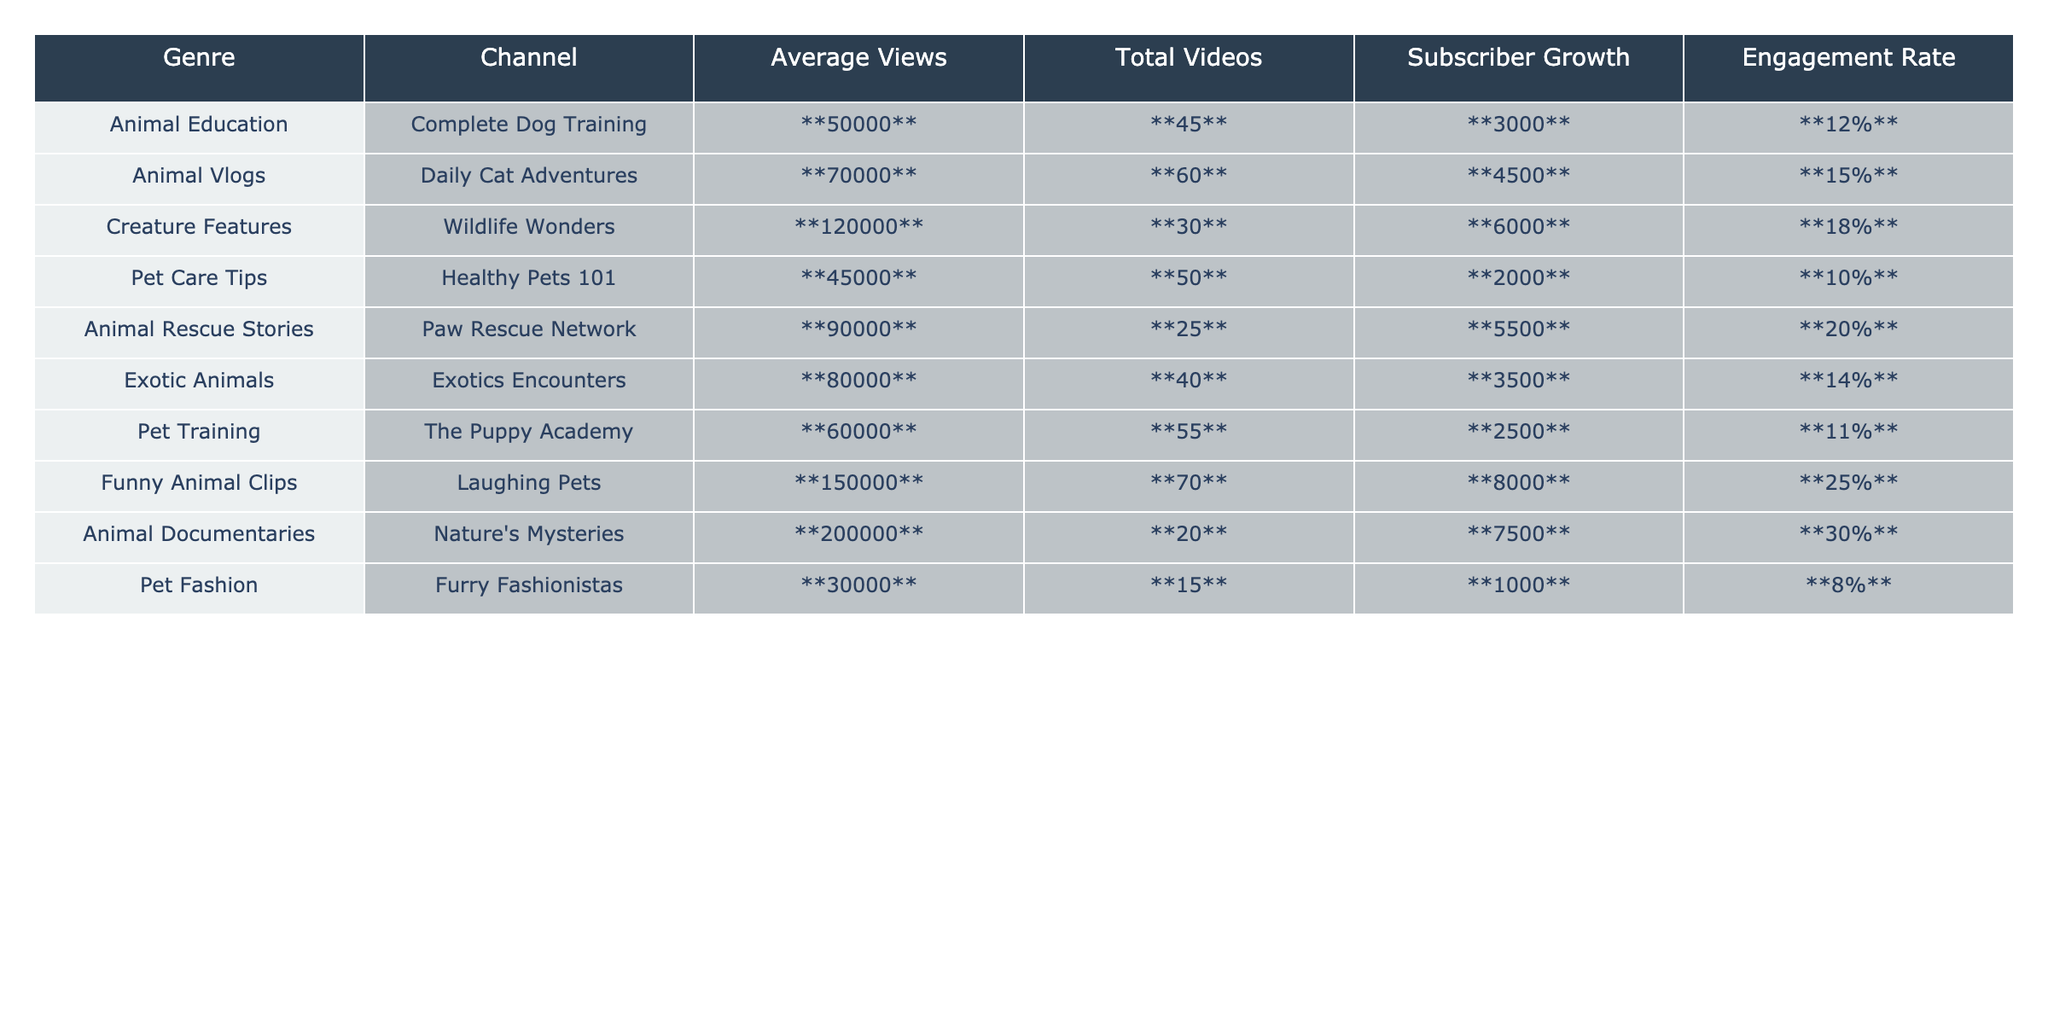What is the average views for the video genre "Funny Animal Clips"? The table indicates that "Funny Animal Clips" has an average of **150000** views according to the data provided.
Answer: 150000 Which video genre has the highest engagement rate? From the table, "Animal Documentaries" has the highest engagement rate of **30%**.
Answer: 30% How many total videos are there in the "Animal Education" genre? The data for "Animal Education" shows that there are **45** total videos according to the table.
Answer: 45 What is the total subscriber growth across all genres? By adding the subscriber growth of each genre: 3000 + 4500 + 6000 + 2000 + 5500 + 3500 + 2500 + 8000 + 7500 + 1000 = 36000.
Answer: 36000 Which channel has the lowest average views, and what is that number? The channel "Pet Fashion" has the lowest average views of **30000** per the table data.
Answer: 30000 Is the engagement rate for "Pet Care Tips" greater than 12%? According to the table, "Pet Care Tips" has an engagement rate of **10%**, which is not greater than 12%.
Answer: No How does the average views of "Creature Features" compare to "Animal Rescue Stories"? "Creature Features" has an average of **120000** views, while "Animal Rescue Stories" has **90000** views. Since 120000 is greater than 90000, "Creature Features" has a higher average views.
Answer: Higher If we average the engagement rates of all genres, what would that be? The total engagement rates are 12% + 15% + 18% + 10% + 20% + 14% + 11% + 25% + 30% + 8% =  10 rates, yielding an average of (12 + 15 + 18 + 10 + 20 + 14 + 11 + 25 + 30 + 8) / 10 = 16.
Answer: 16 Which genre has the highest average views and combination of total videos less than 50? "Pet Training" (60000 views, 55 videos) and "Animal Rescue Stories" (90000 views, 25 videos) are the options. With total videos less than 50, "Animal Rescue Stories" has 90000 views, thus it is the highest with this condition.
Answer: Animal Rescue Stories What percentage of total videos does the "Exotic Animals" genre represent among all genres? The total number of videos across all genres is 45 + 60 + 30 + 50 + 25 + 40 + 55 + 70 + 20 + 15 = 410. "Exotic Animals" has 40 videos, (40/410)*100 = 9.76%.
Answer: 9.76% 